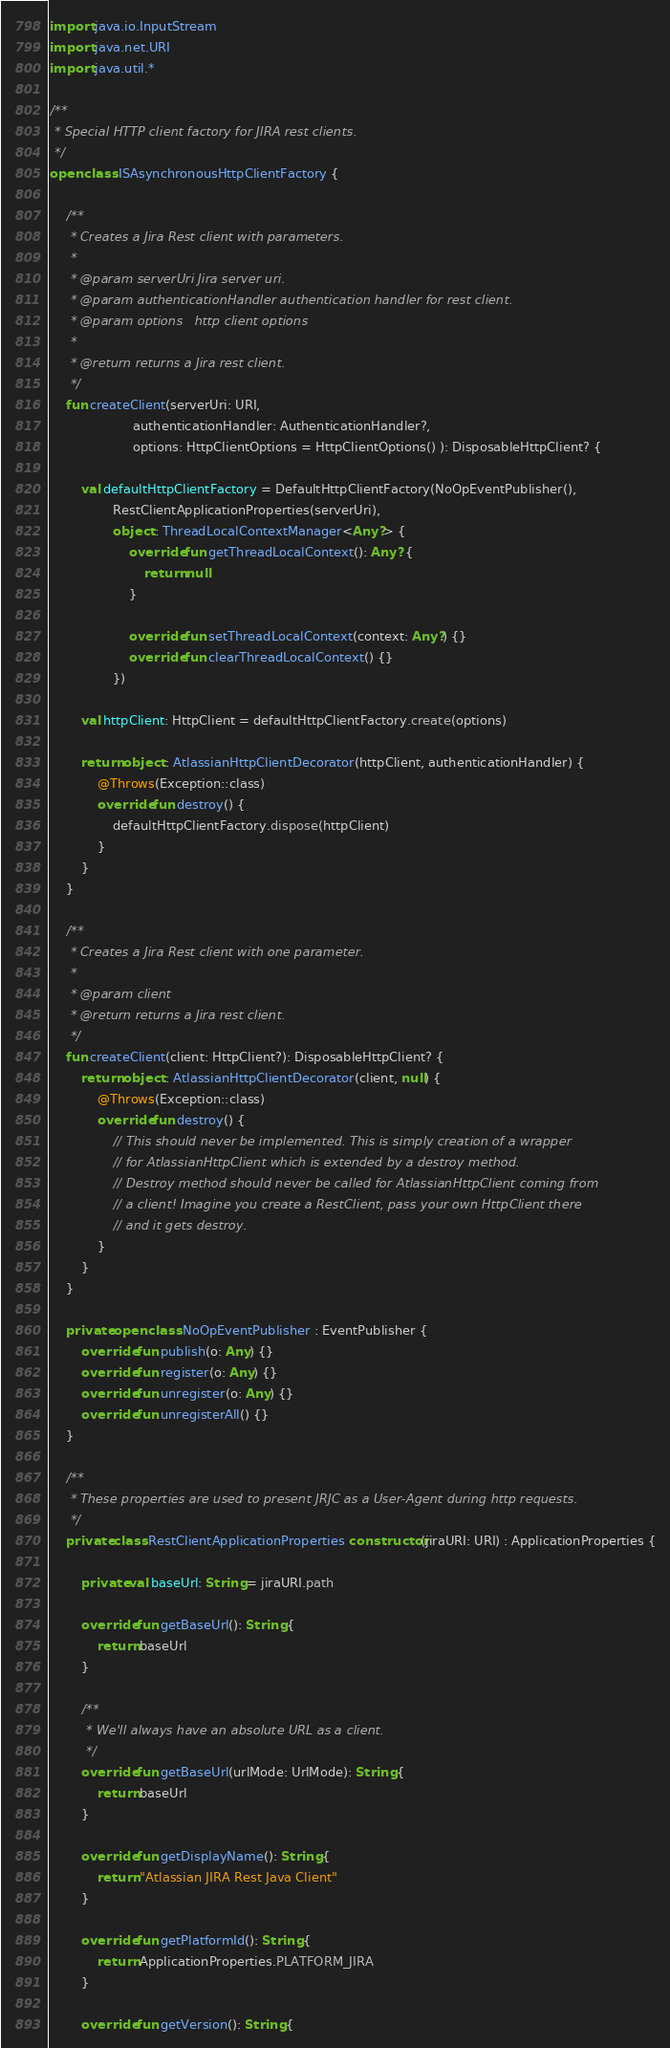Convert code to text. <code><loc_0><loc_0><loc_500><loc_500><_Kotlin_>import java.io.InputStream
import java.net.URI
import java.util.*

/**
 * Special HTTP client factory for JIRA rest clients.
 */
open class ISAsynchronousHttpClientFactory {

    /**
     * Creates a Jira Rest client with parameters.
     *
     * @param serverUri Jira server uri.
     * @param authenticationHandler authentication handler for rest client.
     * @param options   http client options
     *
     * @return returns a Jira rest client.
     */
    fun createClient(serverUri: URI,
                     authenticationHandler: AuthenticationHandler?,
                     options: HttpClientOptions = HttpClientOptions() ): DisposableHttpClient? {

        val defaultHttpClientFactory = DefaultHttpClientFactory(NoOpEventPublisher(),
                RestClientApplicationProperties(serverUri),
                object : ThreadLocalContextManager<Any?> {
                    override fun getThreadLocalContext(): Any? {
                        return null
                    }

                    override fun setThreadLocalContext(context: Any?) {}
                    override fun clearThreadLocalContext() {}
                })

        val httpClient: HttpClient = defaultHttpClientFactory.create(options)

        return object : AtlassianHttpClientDecorator(httpClient, authenticationHandler) {
            @Throws(Exception::class)
            override fun destroy() {
                defaultHttpClientFactory.dispose(httpClient)
            }
        }
    }

    /**
     * Creates a Jira Rest client with one parameter.
     *
     * @param client
     * @return returns a Jira rest client.
     */
    fun createClient(client: HttpClient?): DisposableHttpClient? {
        return object : AtlassianHttpClientDecorator(client, null) {
            @Throws(Exception::class)
            override fun destroy() {
                // This should never be implemented. This is simply creation of a wrapper
                // for AtlassianHttpClient which is extended by a destroy method.
                // Destroy method should never be called for AtlassianHttpClient coming from
                // a client! Imagine you create a RestClient, pass your own HttpClient there
                // and it gets destroy.
            }
        }
    }

    private open class NoOpEventPublisher : EventPublisher {
        override fun publish(o: Any) {}
        override fun register(o: Any) {}
        override fun unregister(o: Any) {}
        override fun unregisterAll() {}
    }

    /**
     * These properties are used to present JRJC as a User-Agent during http requests.
     */
    private class RestClientApplicationProperties constructor(jiraURI: URI) : ApplicationProperties {

        private val baseUrl: String = jiraURI.path

        override fun getBaseUrl(): String {
            return baseUrl
        }

        /**
         * We'll always have an absolute URL as a client.
         */
        override fun getBaseUrl(urlMode: UrlMode): String {
            return baseUrl
        }

        override fun getDisplayName(): String {
            return "Atlassian JIRA Rest Java Client"
        }

        override fun getPlatformId(): String {
            return ApplicationProperties.PLATFORM_JIRA
        }

        override fun getVersion(): String {</code> 